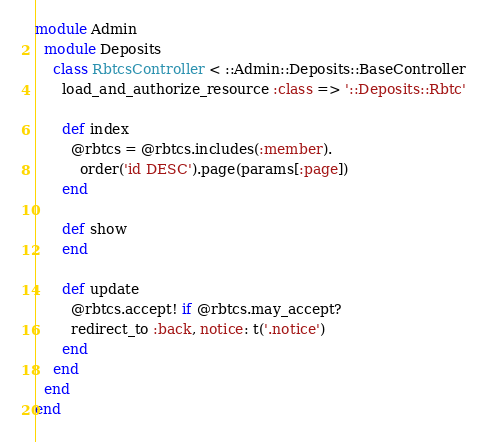Convert code to text. <code><loc_0><loc_0><loc_500><loc_500><_Ruby_>module Admin
  module Deposits
    class RbtcsController < ::Admin::Deposits::BaseController
      load_and_authorize_resource :class => '::Deposits::Rbtc'

      def index
        @rbtcs = @rbtcs.includes(:member).
          order('id DESC').page(params[:page])
      end

      def show
      end

      def update
        @rbtcs.accept! if @rbtcs.may_accept?
        redirect_to :back, notice: t('.notice')
      end
    end
  end
end
</code> 